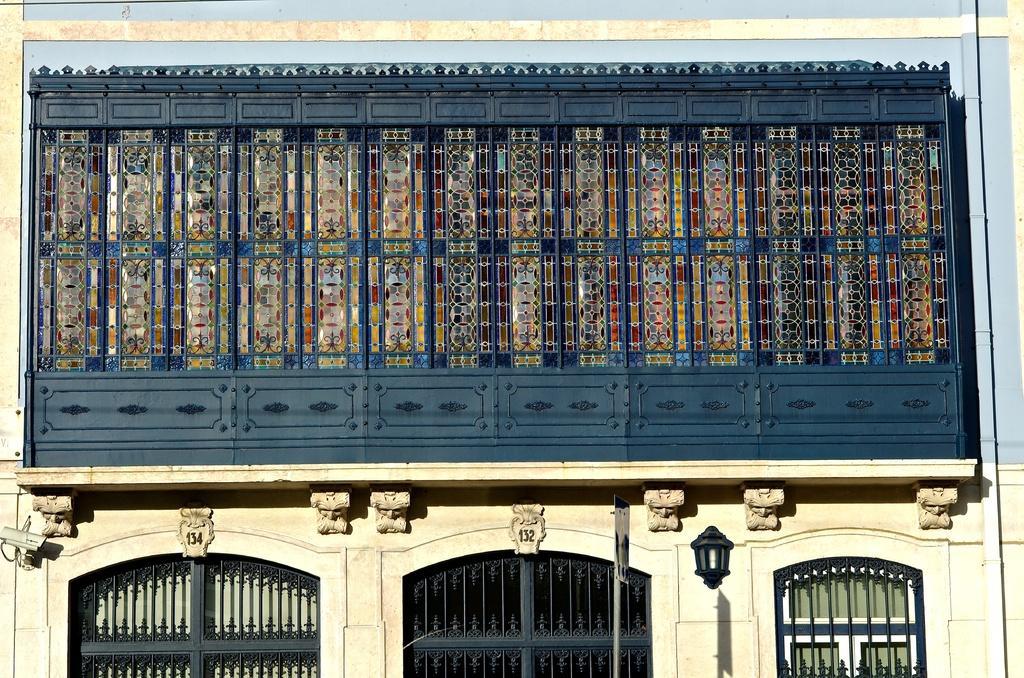Please provide a concise description of this image. In this picture we can see a building. On this building, we can see a few rods, lantern and other things. 